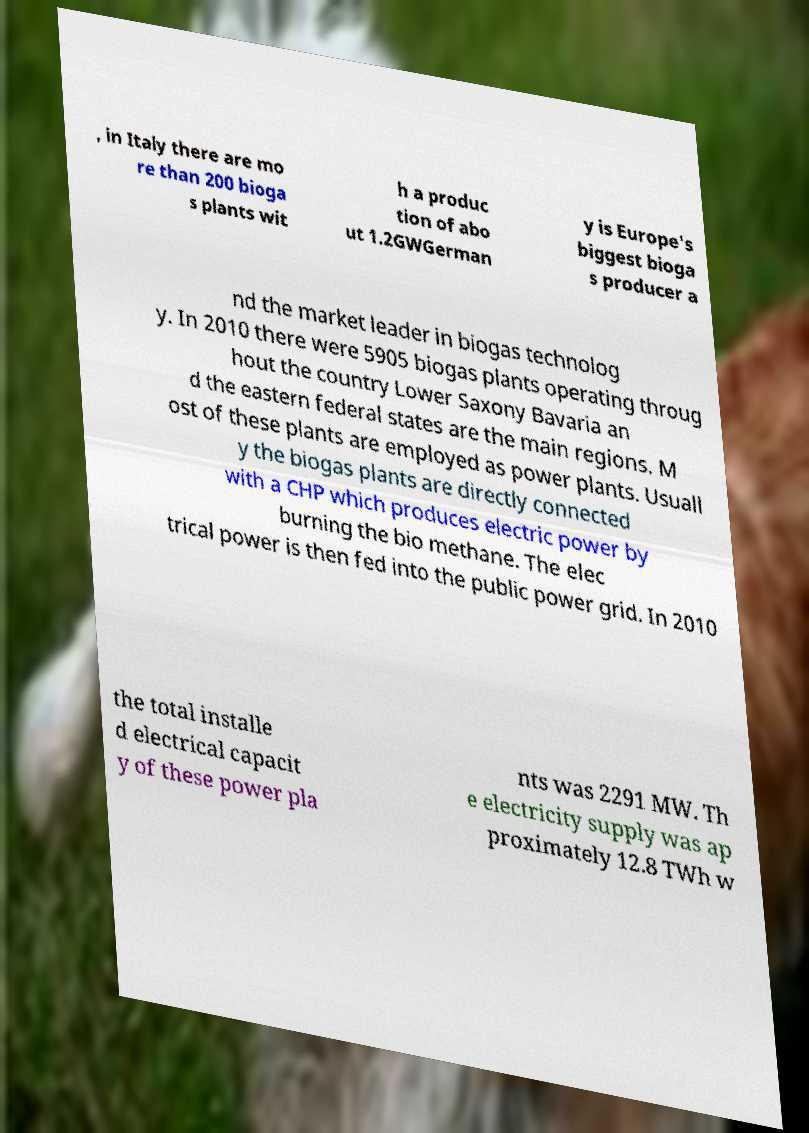For documentation purposes, I need the text within this image transcribed. Could you provide that? , in Italy there are mo re than 200 bioga s plants wit h a produc tion of abo ut 1.2GWGerman y is Europe's biggest bioga s producer a nd the market leader in biogas technolog y. In 2010 there were 5905 biogas plants operating throug hout the country Lower Saxony Bavaria an d the eastern federal states are the main regions. M ost of these plants are employed as power plants. Usuall y the biogas plants are directly connected with a CHP which produces electric power by burning the bio methane. The elec trical power is then fed into the public power grid. In 2010 the total installe d electrical capacit y of these power pla nts was 2291 MW. Th e electricity supply was ap proximately 12.8 TWh w 